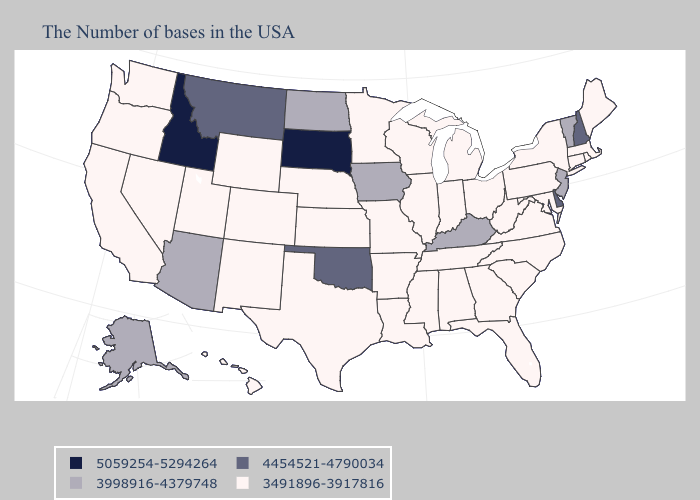Name the states that have a value in the range 4454521-4790034?
Answer briefly. New Hampshire, Delaware, Oklahoma, Montana. Which states have the lowest value in the USA?
Answer briefly. Maine, Massachusetts, Rhode Island, Connecticut, New York, Maryland, Pennsylvania, Virginia, North Carolina, South Carolina, West Virginia, Ohio, Florida, Georgia, Michigan, Indiana, Alabama, Tennessee, Wisconsin, Illinois, Mississippi, Louisiana, Missouri, Arkansas, Minnesota, Kansas, Nebraska, Texas, Wyoming, Colorado, New Mexico, Utah, Nevada, California, Washington, Oregon, Hawaii. Does New Jersey have the lowest value in the Northeast?
Write a very short answer. No. What is the highest value in the West ?
Quick response, please. 5059254-5294264. Does South Dakota have the highest value in the USA?
Give a very brief answer. Yes. Among the states that border Illinois , does Iowa have the lowest value?
Answer briefly. No. Among the states that border Texas , does New Mexico have the highest value?
Quick response, please. No. Name the states that have a value in the range 4454521-4790034?
Give a very brief answer. New Hampshire, Delaware, Oklahoma, Montana. What is the value of Kansas?
Keep it brief. 3491896-3917816. Among the states that border Texas , does Louisiana have the highest value?
Be succinct. No. Name the states that have a value in the range 5059254-5294264?
Be succinct. South Dakota, Idaho. Among the states that border North Carolina , which have the lowest value?
Be succinct. Virginia, South Carolina, Georgia, Tennessee. Does South Dakota have the highest value in the MidWest?
Write a very short answer. Yes. Name the states that have a value in the range 3491896-3917816?
Quick response, please. Maine, Massachusetts, Rhode Island, Connecticut, New York, Maryland, Pennsylvania, Virginia, North Carolina, South Carolina, West Virginia, Ohio, Florida, Georgia, Michigan, Indiana, Alabama, Tennessee, Wisconsin, Illinois, Mississippi, Louisiana, Missouri, Arkansas, Minnesota, Kansas, Nebraska, Texas, Wyoming, Colorado, New Mexico, Utah, Nevada, California, Washington, Oregon, Hawaii. What is the value of South Carolina?
Quick response, please. 3491896-3917816. 